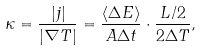<formula> <loc_0><loc_0><loc_500><loc_500>\kappa = \frac { | j | } { | \nabla T | } = \frac { \langle \Delta E \rangle } { A \Delta t } \cdot \frac { L / 2 } { 2 \Delta T } ,</formula> 